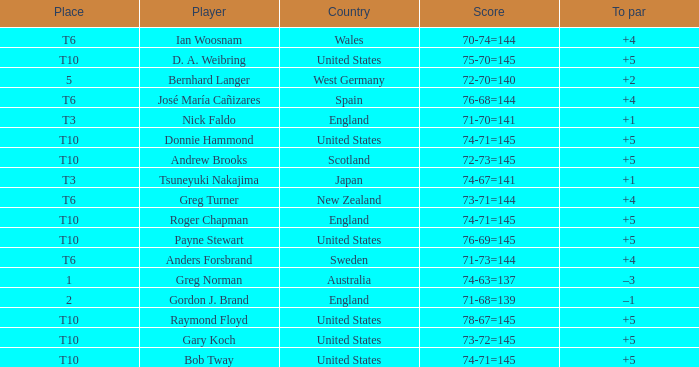Which player scored 76-68=144? José María Cañizares. 